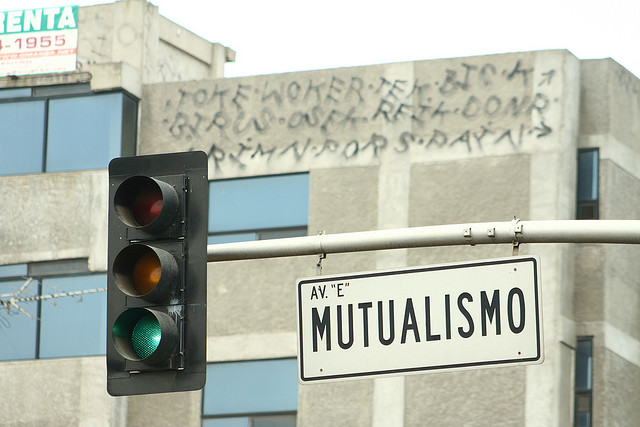Extract all visible text content from this image. ENTA 1955 MUTUALISMO AV E PAIN S POR RIMN BIRUS OSFK RFIK DONR BIO4 TEK WOKER TOKE 